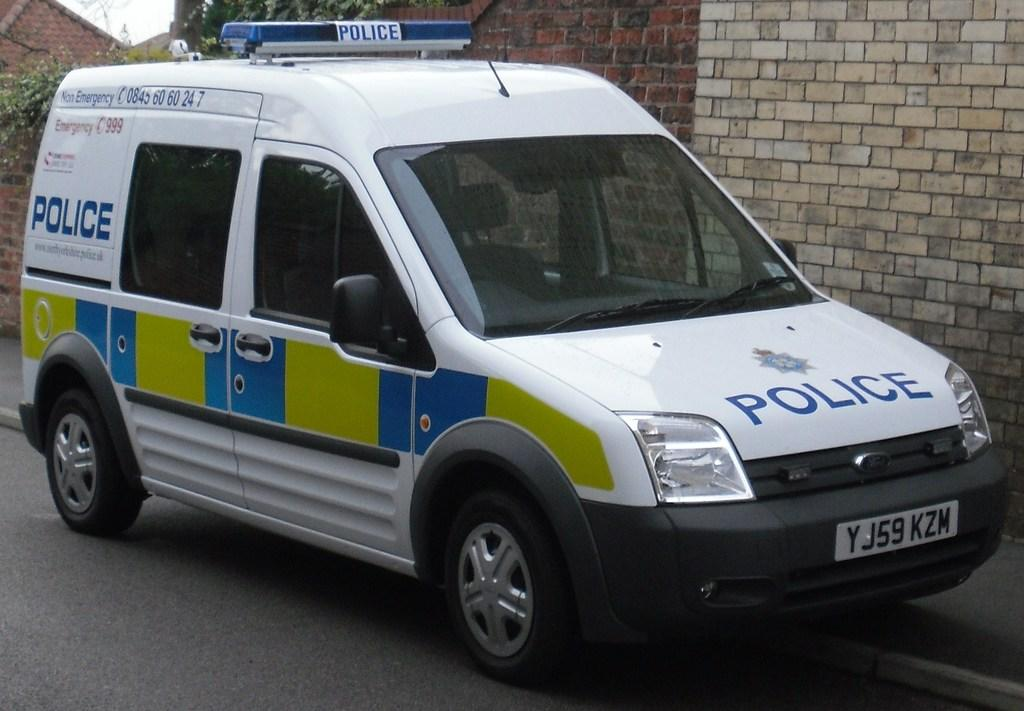<image>
Describe the image concisely. A white green and blue van with a police logo on its hood is parked next to a brick wall. 